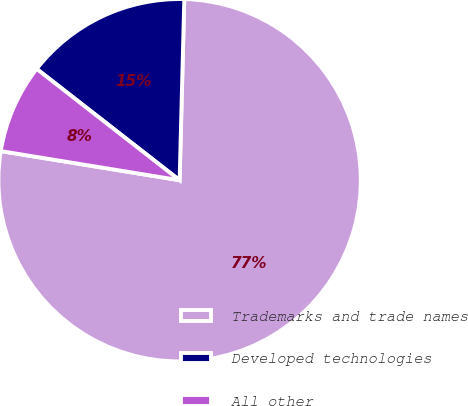Convert chart. <chart><loc_0><loc_0><loc_500><loc_500><pie_chart><fcel>Trademarks and trade names<fcel>Developed technologies<fcel>All other<nl><fcel>77.16%<fcel>14.88%<fcel>7.96%<nl></chart> 